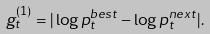<formula> <loc_0><loc_0><loc_500><loc_500>g ^ { ( 1 ) } _ { t } = | \log p ^ { b e s t } _ { t } - \log p ^ { n e x t } _ { t } | .</formula> 